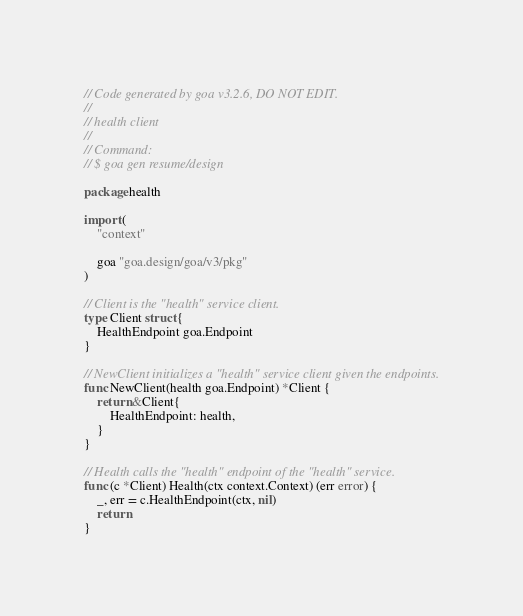Convert code to text. <code><loc_0><loc_0><loc_500><loc_500><_Go_>// Code generated by goa v3.2.6, DO NOT EDIT.
//
// health client
//
// Command:
// $ goa gen resume/design

package health

import (
	"context"

	goa "goa.design/goa/v3/pkg"
)

// Client is the "health" service client.
type Client struct {
	HealthEndpoint goa.Endpoint
}

// NewClient initializes a "health" service client given the endpoints.
func NewClient(health goa.Endpoint) *Client {
	return &Client{
		HealthEndpoint: health,
	}
}

// Health calls the "health" endpoint of the "health" service.
func (c *Client) Health(ctx context.Context) (err error) {
	_, err = c.HealthEndpoint(ctx, nil)
	return
}
</code> 